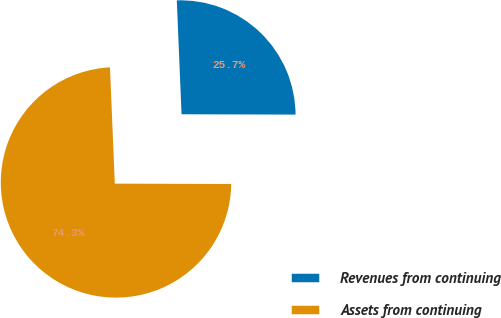<chart> <loc_0><loc_0><loc_500><loc_500><pie_chart><fcel>Revenues from continuing<fcel>Assets from continuing<nl><fcel>25.71%<fcel>74.29%<nl></chart> 